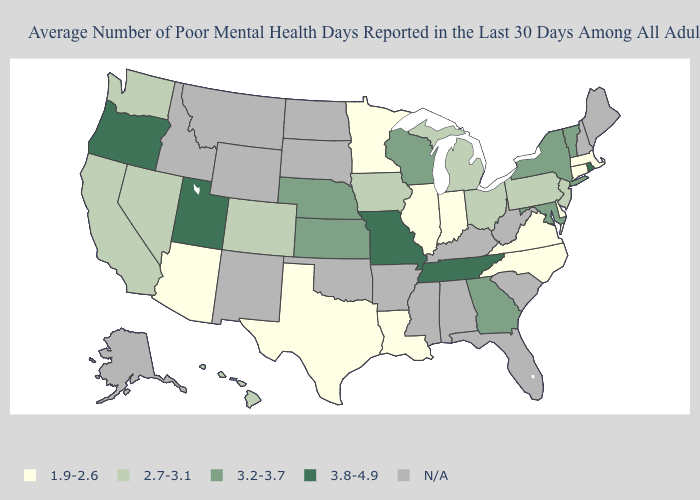Name the states that have a value in the range N/A?
Be succinct. Alabama, Alaska, Arkansas, Florida, Idaho, Kentucky, Maine, Mississippi, Montana, New Hampshire, New Mexico, North Dakota, Oklahoma, South Carolina, South Dakota, West Virginia, Wyoming. What is the lowest value in states that border Connecticut?
Answer briefly. 1.9-2.6. What is the value of South Dakota?
Be succinct. N/A. Among the states that border Washington , which have the lowest value?
Answer briefly. Oregon. Name the states that have a value in the range 1.9-2.6?
Write a very short answer. Arizona, Connecticut, Delaware, Illinois, Indiana, Louisiana, Massachusetts, Minnesota, North Carolina, Texas, Virginia. What is the highest value in states that border Arkansas?
Write a very short answer. 3.8-4.9. Does Rhode Island have the lowest value in the USA?
Answer briefly. No. Does the first symbol in the legend represent the smallest category?
Quick response, please. Yes. Does the map have missing data?
Keep it brief. Yes. What is the highest value in the USA?
Be succinct. 3.8-4.9. Does the first symbol in the legend represent the smallest category?
Quick response, please. Yes. Does Rhode Island have the highest value in the Northeast?
Be succinct. Yes. What is the lowest value in the USA?
Answer briefly. 1.9-2.6. What is the value of Michigan?
Write a very short answer. 2.7-3.1. 